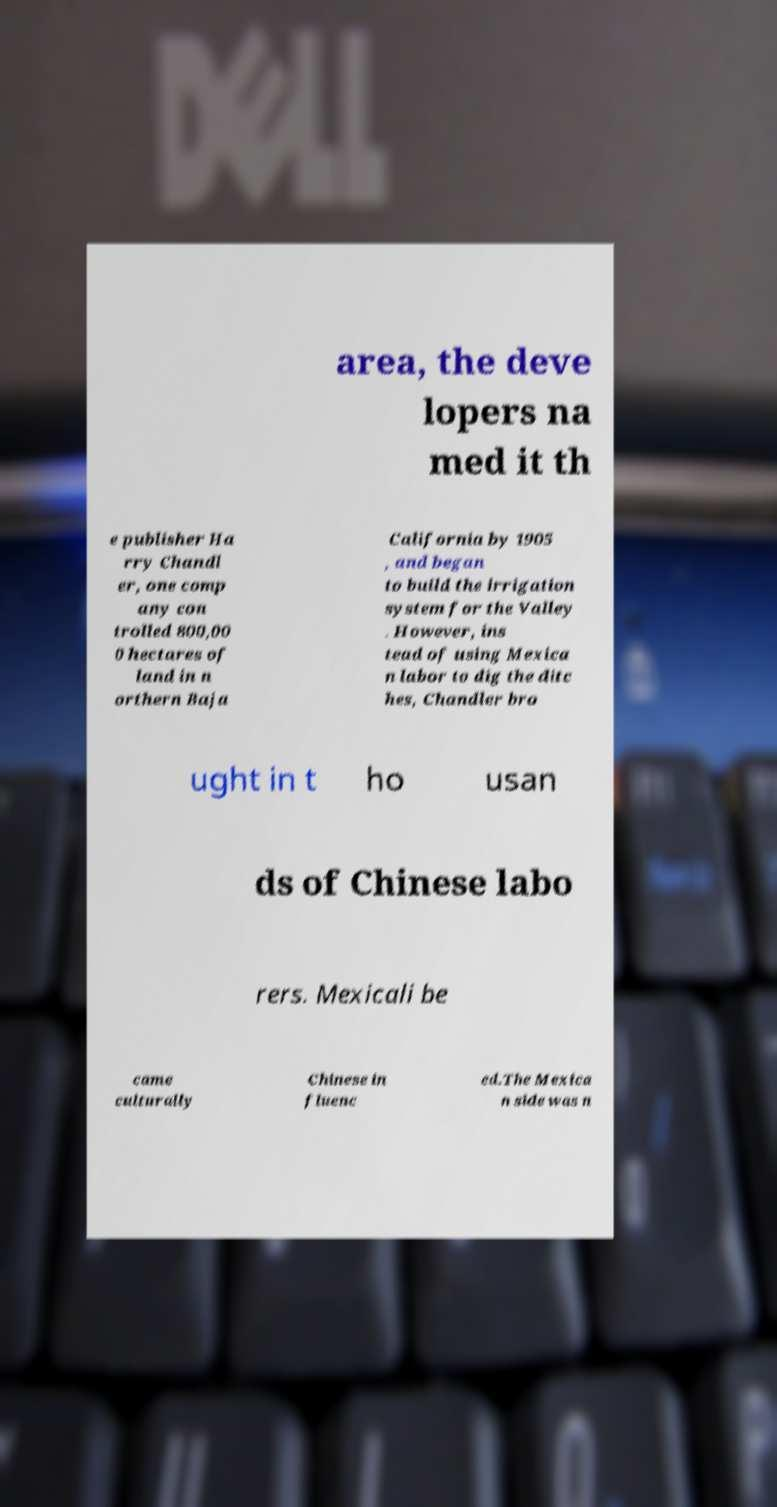What messages or text are displayed in this image? I need them in a readable, typed format. area, the deve lopers na med it th e publisher Ha rry Chandl er, one comp any con trolled 800,00 0 hectares of land in n orthern Baja California by 1905 , and began to build the irrigation system for the Valley . However, ins tead of using Mexica n labor to dig the ditc hes, Chandler bro ught in t ho usan ds of Chinese labo rers. Mexicali be came culturally Chinese in fluenc ed.The Mexica n side was n 